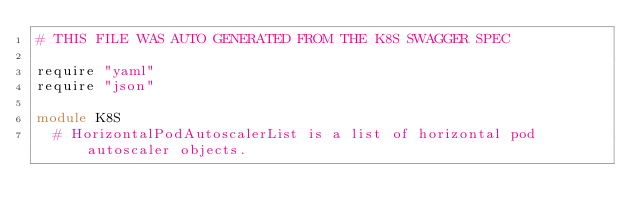<code> <loc_0><loc_0><loc_500><loc_500><_Crystal_># THIS FILE WAS AUTO GENERATED FROM THE K8S SWAGGER SPEC

require "yaml"
require "json"

module K8S
  # HorizontalPodAutoscalerList is a list of horizontal pod autoscaler objects.</code> 